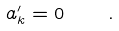Convert formula to latex. <formula><loc_0><loc_0><loc_500><loc_500>a ^ { \prime } _ { k } = 0 \quad .</formula> 